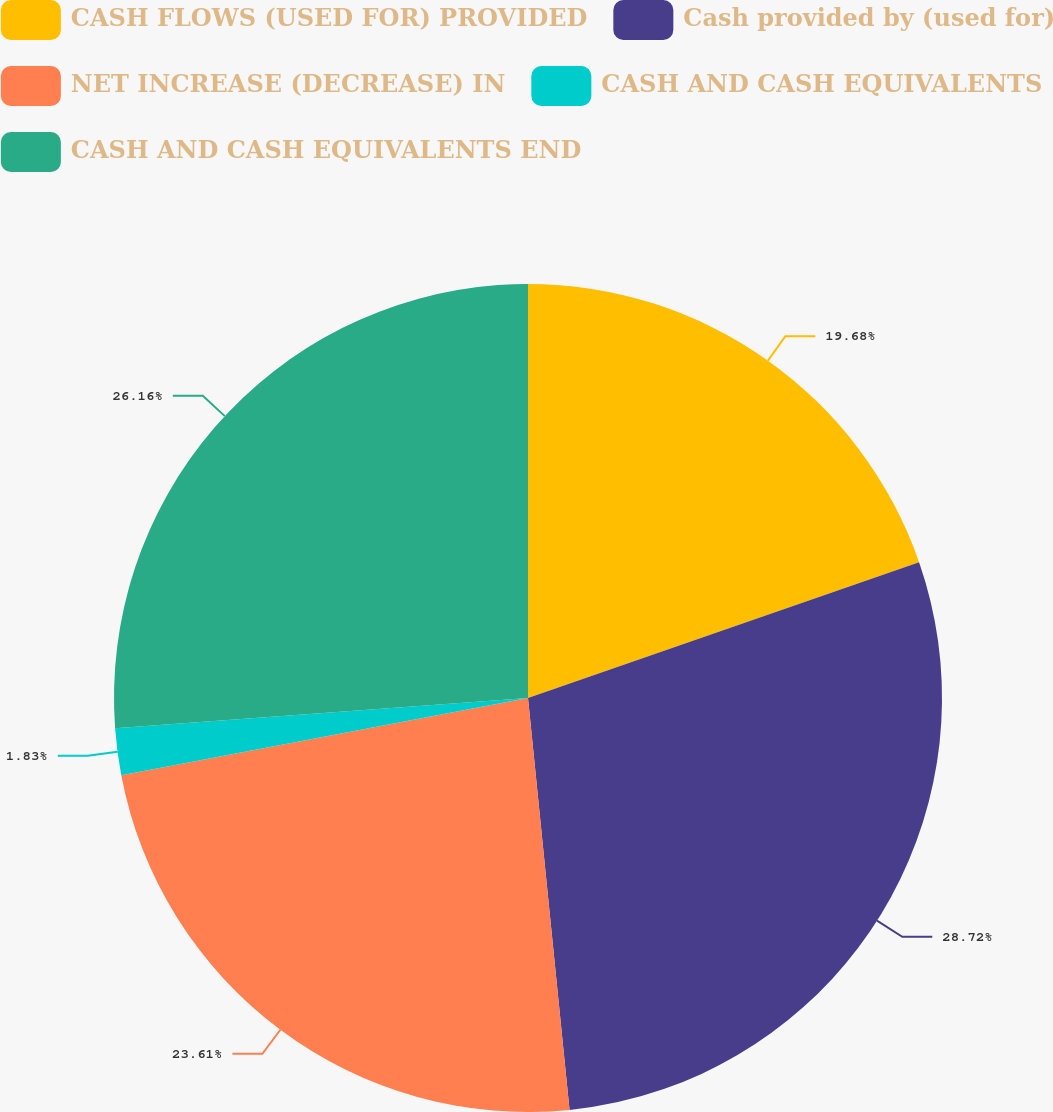Convert chart to OTSL. <chart><loc_0><loc_0><loc_500><loc_500><pie_chart><fcel>CASH FLOWS (USED FOR) PROVIDED<fcel>Cash provided by (used for)<fcel>NET INCREASE (DECREASE) IN<fcel>CASH AND CASH EQUIVALENTS<fcel>CASH AND CASH EQUIVALENTS END<nl><fcel>19.68%<fcel>28.72%<fcel>23.61%<fcel>1.83%<fcel>26.16%<nl></chart> 